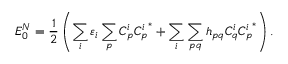<formula> <loc_0><loc_0><loc_500><loc_500>E _ { 0 } ^ { N } = \frac { 1 } { 2 } \left ( \sum _ { i } \varepsilon _ { i } \sum _ { p } C _ { p } ^ { i } { C _ { p } ^ { i } } ^ { * } + \sum _ { i } \sum _ { p q } h _ { p q } C _ { q } ^ { i } { C _ { p } ^ { i } } ^ { * } \right ) .</formula> 